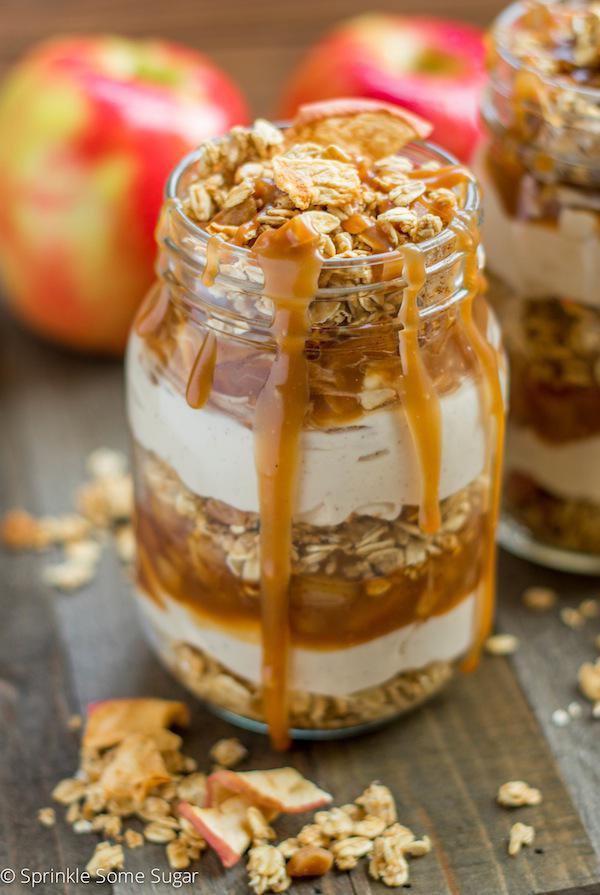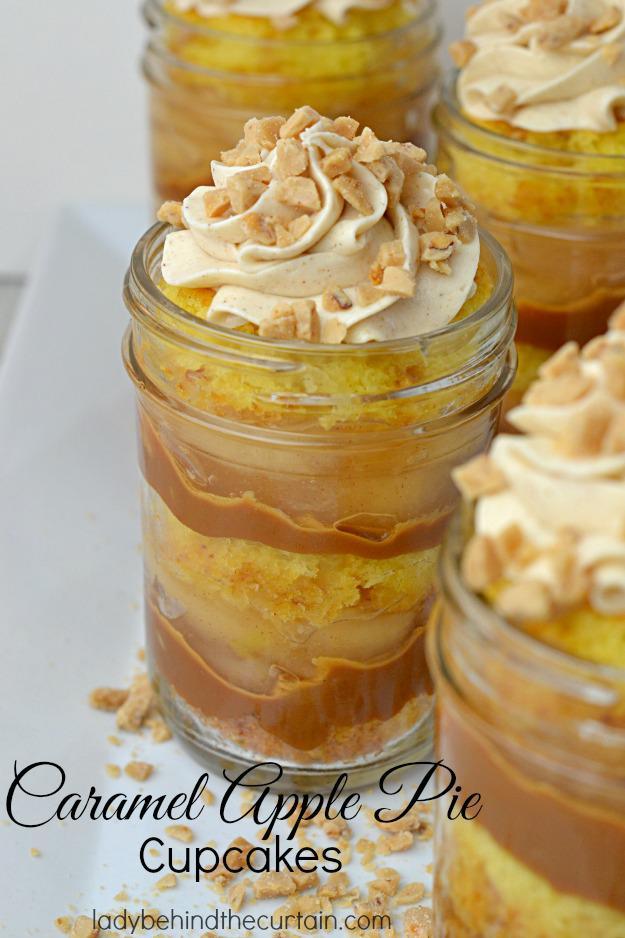The first image is the image on the left, the second image is the image on the right. Assess this claim about the two images: "Caramel is dripping over a jar of dessert.". Correct or not? Answer yes or no. Yes. The first image is the image on the left, the second image is the image on the right. For the images displayed, is the sentence "An image shows a dessert with two white layers, no whipped cream on top, and caramel drizzled down the exterior of the serving jar." factually correct? Answer yes or no. Yes. 